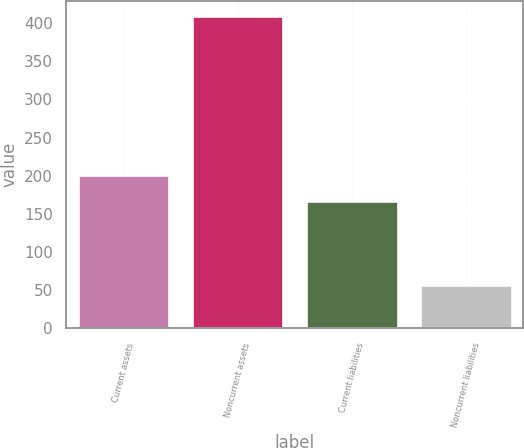<chart> <loc_0><loc_0><loc_500><loc_500><bar_chart><fcel>Current assets<fcel>Noncurrent assets<fcel>Current liabilities<fcel>Noncurrent liabilities<nl><fcel>201.58<fcel>408.6<fcel>166.4<fcel>56.8<nl></chart> 